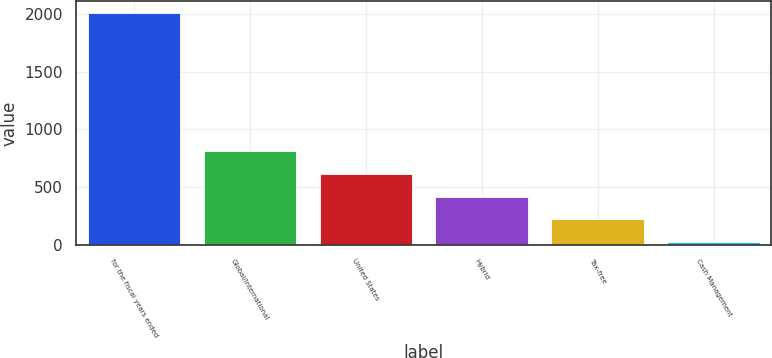<chart> <loc_0><loc_0><loc_500><loc_500><bar_chart><fcel>for the fiscal years ended<fcel>Global/international<fcel>United States<fcel>Hybrid<fcel>Tax-free<fcel>Cash Management<nl><fcel>2009<fcel>815.6<fcel>616.7<fcel>417.8<fcel>218.9<fcel>20<nl></chart> 